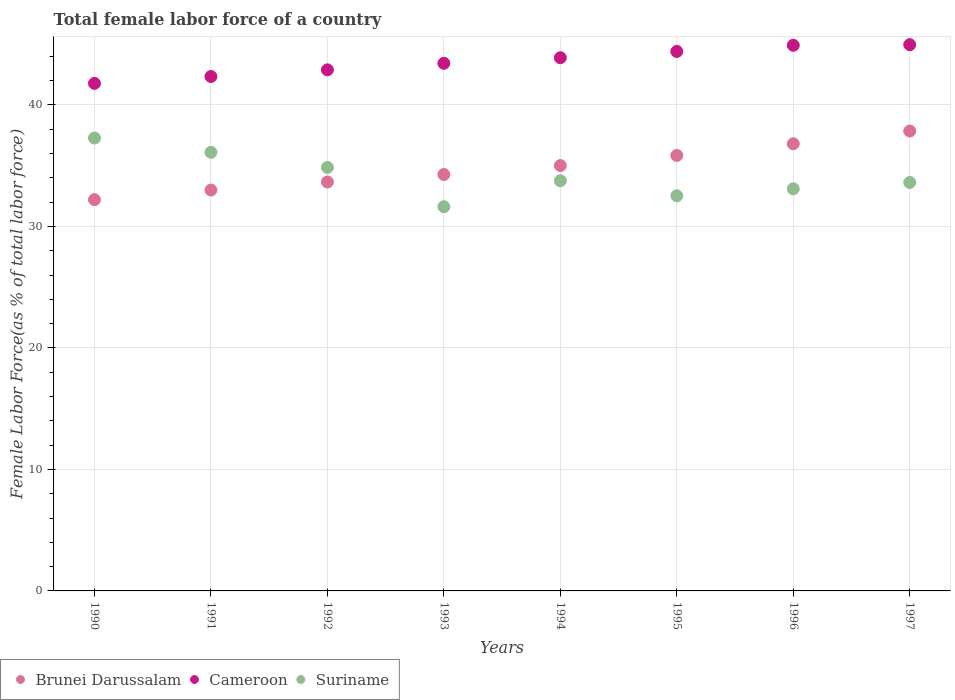How many different coloured dotlines are there?
Your answer should be very brief. 3. What is the percentage of female labor force in Cameroon in 1990?
Your answer should be very brief. 41.78. Across all years, what is the maximum percentage of female labor force in Cameroon?
Provide a short and direct response. 44.96. Across all years, what is the minimum percentage of female labor force in Suriname?
Your response must be concise. 31.62. In which year was the percentage of female labor force in Suriname maximum?
Your response must be concise. 1990. What is the total percentage of female labor force in Suriname in the graph?
Provide a short and direct response. 272.87. What is the difference between the percentage of female labor force in Suriname in 1990 and that in 1991?
Your answer should be very brief. 1.18. What is the difference between the percentage of female labor force in Suriname in 1992 and the percentage of female labor force in Brunei Darussalam in 1995?
Give a very brief answer. -0.99. What is the average percentage of female labor force in Cameroon per year?
Provide a succinct answer. 43.58. In the year 1990, what is the difference between the percentage of female labor force in Cameroon and percentage of female labor force in Brunei Darussalam?
Your answer should be compact. 9.57. What is the ratio of the percentage of female labor force in Cameroon in 1992 to that in 1994?
Provide a short and direct response. 0.98. Is the difference between the percentage of female labor force in Cameroon in 1990 and 1993 greater than the difference between the percentage of female labor force in Brunei Darussalam in 1990 and 1993?
Your answer should be very brief. Yes. What is the difference between the highest and the second highest percentage of female labor force in Suriname?
Offer a very short reply. 1.18. What is the difference between the highest and the lowest percentage of female labor force in Brunei Darussalam?
Your response must be concise. 5.65. In how many years, is the percentage of female labor force in Brunei Darussalam greater than the average percentage of female labor force in Brunei Darussalam taken over all years?
Ensure brevity in your answer.  4. Is it the case that in every year, the sum of the percentage of female labor force in Cameroon and percentage of female labor force in Brunei Darussalam  is greater than the percentage of female labor force in Suriname?
Ensure brevity in your answer.  Yes. Is the percentage of female labor force in Suriname strictly greater than the percentage of female labor force in Brunei Darussalam over the years?
Provide a short and direct response. No. Is the percentage of female labor force in Suriname strictly less than the percentage of female labor force in Brunei Darussalam over the years?
Your response must be concise. No. How many years are there in the graph?
Provide a short and direct response. 8. Does the graph contain any zero values?
Your answer should be very brief. No. Does the graph contain grids?
Offer a terse response. Yes. What is the title of the graph?
Give a very brief answer. Total female labor force of a country. What is the label or title of the Y-axis?
Your response must be concise. Female Labor Force(as % of total labor force). What is the Female Labor Force(as % of total labor force) in Brunei Darussalam in 1990?
Keep it short and to the point. 32.2. What is the Female Labor Force(as % of total labor force) in Cameroon in 1990?
Ensure brevity in your answer.  41.78. What is the Female Labor Force(as % of total labor force) in Suriname in 1990?
Give a very brief answer. 37.28. What is the Female Labor Force(as % of total labor force) of Brunei Darussalam in 1991?
Your response must be concise. 33. What is the Female Labor Force(as % of total labor force) in Cameroon in 1991?
Give a very brief answer. 42.34. What is the Female Labor Force(as % of total labor force) in Suriname in 1991?
Ensure brevity in your answer.  36.1. What is the Female Labor Force(as % of total labor force) of Brunei Darussalam in 1992?
Make the answer very short. 33.66. What is the Female Labor Force(as % of total labor force) of Cameroon in 1992?
Give a very brief answer. 42.89. What is the Female Labor Force(as % of total labor force) of Suriname in 1992?
Your response must be concise. 34.86. What is the Female Labor Force(as % of total labor force) of Brunei Darussalam in 1993?
Make the answer very short. 34.28. What is the Female Labor Force(as % of total labor force) in Cameroon in 1993?
Give a very brief answer. 43.43. What is the Female Labor Force(as % of total labor force) of Suriname in 1993?
Your answer should be very brief. 31.62. What is the Female Labor Force(as % of total labor force) of Brunei Darussalam in 1994?
Give a very brief answer. 35.01. What is the Female Labor Force(as % of total labor force) of Cameroon in 1994?
Ensure brevity in your answer.  43.89. What is the Female Labor Force(as % of total labor force) of Suriname in 1994?
Provide a short and direct response. 33.76. What is the Female Labor Force(as % of total labor force) in Brunei Darussalam in 1995?
Offer a terse response. 35.85. What is the Female Labor Force(as % of total labor force) in Cameroon in 1995?
Offer a very short reply. 44.4. What is the Female Labor Force(as % of total labor force) of Suriname in 1995?
Provide a short and direct response. 32.53. What is the Female Labor Force(as % of total labor force) in Brunei Darussalam in 1996?
Offer a very short reply. 36.81. What is the Female Labor Force(as % of total labor force) of Cameroon in 1996?
Provide a succinct answer. 44.91. What is the Female Labor Force(as % of total labor force) of Suriname in 1996?
Ensure brevity in your answer.  33.1. What is the Female Labor Force(as % of total labor force) in Brunei Darussalam in 1997?
Offer a terse response. 37.86. What is the Female Labor Force(as % of total labor force) in Cameroon in 1997?
Offer a terse response. 44.96. What is the Female Labor Force(as % of total labor force) of Suriname in 1997?
Provide a succinct answer. 33.62. Across all years, what is the maximum Female Labor Force(as % of total labor force) in Brunei Darussalam?
Provide a short and direct response. 37.86. Across all years, what is the maximum Female Labor Force(as % of total labor force) of Cameroon?
Offer a very short reply. 44.96. Across all years, what is the maximum Female Labor Force(as % of total labor force) of Suriname?
Make the answer very short. 37.28. Across all years, what is the minimum Female Labor Force(as % of total labor force) in Brunei Darussalam?
Your answer should be compact. 32.2. Across all years, what is the minimum Female Labor Force(as % of total labor force) in Cameroon?
Provide a succinct answer. 41.78. Across all years, what is the minimum Female Labor Force(as % of total labor force) of Suriname?
Your response must be concise. 31.62. What is the total Female Labor Force(as % of total labor force) of Brunei Darussalam in the graph?
Offer a very short reply. 278.66. What is the total Female Labor Force(as % of total labor force) of Cameroon in the graph?
Offer a very short reply. 348.61. What is the total Female Labor Force(as % of total labor force) in Suriname in the graph?
Your answer should be compact. 272.87. What is the difference between the Female Labor Force(as % of total labor force) in Brunei Darussalam in 1990 and that in 1991?
Your answer should be compact. -0.79. What is the difference between the Female Labor Force(as % of total labor force) in Cameroon in 1990 and that in 1991?
Ensure brevity in your answer.  -0.57. What is the difference between the Female Labor Force(as % of total labor force) in Suriname in 1990 and that in 1991?
Your answer should be very brief. 1.18. What is the difference between the Female Labor Force(as % of total labor force) of Brunei Darussalam in 1990 and that in 1992?
Your answer should be very brief. -1.46. What is the difference between the Female Labor Force(as % of total labor force) of Cameroon in 1990 and that in 1992?
Make the answer very short. -1.11. What is the difference between the Female Labor Force(as % of total labor force) of Suriname in 1990 and that in 1992?
Offer a terse response. 2.42. What is the difference between the Female Labor Force(as % of total labor force) in Brunei Darussalam in 1990 and that in 1993?
Provide a short and direct response. -2.07. What is the difference between the Female Labor Force(as % of total labor force) of Cameroon in 1990 and that in 1993?
Your response must be concise. -1.65. What is the difference between the Female Labor Force(as % of total labor force) in Suriname in 1990 and that in 1993?
Make the answer very short. 5.66. What is the difference between the Female Labor Force(as % of total labor force) of Brunei Darussalam in 1990 and that in 1994?
Offer a terse response. -2.81. What is the difference between the Female Labor Force(as % of total labor force) in Cameroon in 1990 and that in 1994?
Ensure brevity in your answer.  -2.11. What is the difference between the Female Labor Force(as % of total labor force) in Suriname in 1990 and that in 1994?
Your response must be concise. 3.52. What is the difference between the Female Labor Force(as % of total labor force) in Brunei Darussalam in 1990 and that in 1995?
Your response must be concise. -3.64. What is the difference between the Female Labor Force(as % of total labor force) of Cameroon in 1990 and that in 1995?
Ensure brevity in your answer.  -2.63. What is the difference between the Female Labor Force(as % of total labor force) in Suriname in 1990 and that in 1995?
Keep it short and to the point. 4.75. What is the difference between the Female Labor Force(as % of total labor force) of Brunei Darussalam in 1990 and that in 1996?
Keep it short and to the point. -4.6. What is the difference between the Female Labor Force(as % of total labor force) in Cameroon in 1990 and that in 1996?
Your response must be concise. -3.13. What is the difference between the Female Labor Force(as % of total labor force) of Suriname in 1990 and that in 1996?
Keep it short and to the point. 4.18. What is the difference between the Female Labor Force(as % of total labor force) of Brunei Darussalam in 1990 and that in 1997?
Provide a succinct answer. -5.65. What is the difference between the Female Labor Force(as % of total labor force) in Cameroon in 1990 and that in 1997?
Provide a short and direct response. -3.19. What is the difference between the Female Labor Force(as % of total labor force) in Suriname in 1990 and that in 1997?
Your response must be concise. 3.65. What is the difference between the Female Labor Force(as % of total labor force) in Brunei Darussalam in 1991 and that in 1992?
Your answer should be very brief. -0.66. What is the difference between the Female Labor Force(as % of total labor force) in Cameroon in 1991 and that in 1992?
Give a very brief answer. -0.55. What is the difference between the Female Labor Force(as % of total labor force) of Suriname in 1991 and that in 1992?
Ensure brevity in your answer.  1.24. What is the difference between the Female Labor Force(as % of total labor force) of Brunei Darussalam in 1991 and that in 1993?
Your response must be concise. -1.28. What is the difference between the Female Labor Force(as % of total labor force) of Cameroon in 1991 and that in 1993?
Your answer should be compact. -1.09. What is the difference between the Female Labor Force(as % of total labor force) in Suriname in 1991 and that in 1993?
Provide a short and direct response. 4.48. What is the difference between the Female Labor Force(as % of total labor force) in Brunei Darussalam in 1991 and that in 1994?
Make the answer very short. -2.02. What is the difference between the Female Labor Force(as % of total labor force) of Cameroon in 1991 and that in 1994?
Offer a terse response. -1.55. What is the difference between the Female Labor Force(as % of total labor force) of Suriname in 1991 and that in 1994?
Your response must be concise. 2.34. What is the difference between the Female Labor Force(as % of total labor force) of Brunei Darussalam in 1991 and that in 1995?
Your answer should be very brief. -2.85. What is the difference between the Female Labor Force(as % of total labor force) of Cameroon in 1991 and that in 1995?
Your answer should be very brief. -2.06. What is the difference between the Female Labor Force(as % of total labor force) of Suriname in 1991 and that in 1995?
Your answer should be compact. 3.58. What is the difference between the Female Labor Force(as % of total labor force) of Brunei Darussalam in 1991 and that in 1996?
Provide a succinct answer. -3.81. What is the difference between the Female Labor Force(as % of total labor force) of Cameroon in 1991 and that in 1996?
Your answer should be very brief. -2.57. What is the difference between the Female Labor Force(as % of total labor force) of Suriname in 1991 and that in 1996?
Make the answer very short. 3. What is the difference between the Female Labor Force(as % of total labor force) of Brunei Darussalam in 1991 and that in 1997?
Offer a very short reply. -4.86. What is the difference between the Female Labor Force(as % of total labor force) in Cameroon in 1991 and that in 1997?
Ensure brevity in your answer.  -2.62. What is the difference between the Female Labor Force(as % of total labor force) in Suriname in 1991 and that in 1997?
Ensure brevity in your answer.  2.48. What is the difference between the Female Labor Force(as % of total labor force) in Brunei Darussalam in 1992 and that in 1993?
Provide a short and direct response. -0.62. What is the difference between the Female Labor Force(as % of total labor force) in Cameroon in 1992 and that in 1993?
Your response must be concise. -0.54. What is the difference between the Female Labor Force(as % of total labor force) in Suriname in 1992 and that in 1993?
Your answer should be very brief. 3.24. What is the difference between the Female Labor Force(as % of total labor force) of Brunei Darussalam in 1992 and that in 1994?
Your answer should be compact. -1.35. What is the difference between the Female Labor Force(as % of total labor force) of Cameroon in 1992 and that in 1994?
Your response must be concise. -1. What is the difference between the Female Labor Force(as % of total labor force) in Suriname in 1992 and that in 1994?
Your answer should be compact. 1.1. What is the difference between the Female Labor Force(as % of total labor force) of Brunei Darussalam in 1992 and that in 1995?
Give a very brief answer. -2.19. What is the difference between the Female Labor Force(as % of total labor force) of Cameroon in 1992 and that in 1995?
Give a very brief answer. -1.52. What is the difference between the Female Labor Force(as % of total labor force) of Suriname in 1992 and that in 1995?
Keep it short and to the point. 2.33. What is the difference between the Female Labor Force(as % of total labor force) in Brunei Darussalam in 1992 and that in 1996?
Keep it short and to the point. -3.15. What is the difference between the Female Labor Force(as % of total labor force) in Cameroon in 1992 and that in 1996?
Offer a terse response. -2.02. What is the difference between the Female Labor Force(as % of total labor force) of Suriname in 1992 and that in 1996?
Offer a very short reply. 1.76. What is the difference between the Female Labor Force(as % of total labor force) in Brunei Darussalam in 1992 and that in 1997?
Ensure brevity in your answer.  -4.2. What is the difference between the Female Labor Force(as % of total labor force) of Cameroon in 1992 and that in 1997?
Make the answer very short. -2.07. What is the difference between the Female Labor Force(as % of total labor force) of Suriname in 1992 and that in 1997?
Your answer should be very brief. 1.24. What is the difference between the Female Labor Force(as % of total labor force) of Brunei Darussalam in 1993 and that in 1994?
Your answer should be compact. -0.73. What is the difference between the Female Labor Force(as % of total labor force) in Cameroon in 1993 and that in 1994?
Your response must be concise. -0.46. What is the difference between the Female Labor Force(as % of total labor force) of Suriname in 1993 and that in 1994?
Give a very brief answer. -2.14. What is the difference between the Female Labor Force(as % of total labor force) in Brunei Darussalam in 1993 and that in 1995?
Keep it short and to the point. -1.57. What is the difference between the Female Labor Force(as % of total labor force) in Cameroon in 1993 and that in 1995?
Offer a terse response. -0.97. What is the difference between the Female Labor Force(as % of total labor force) in Suriname in 1993 and that in 1995?
Your answer should be compact. -0.9. What is the difference between the Female Labor Force(as % of total labor force) in Brunei Darussalam in 1993 and that in 1996?
Provide a short and direct response. -2.53. What is the difference between the Female Labor Force(as % of total labor force) in Cameroon in 1993 and that in 1996?
Your response must be concise. -1.48. What is the difference between the Female Labor Force(as % of total labor force) of Suriname in 1993 and that in 1996?
Offer a very short reply. -1.48. What is the difference between the Female Labor Force(as % of total labor force) of Brunei Darussalam in 1993 and that in 1997?
Your response must be concise. -3.58. What is the difference between the Female Labor Force(as % of total labor force) in Cameroon in 1993 and that in 1997?
Your answer should be compact. -1.53. What is the difference between the Female Labor Force(as % of total labor force) of Suriname in 1993 and that in 1997?
Give a very brief answer. -2. What is the difference between the Female Labor Force(as % of total labor force) of Brunei Darussalam in 1994 and that in 1995?
Your answer should be compact. -0.83. What is the difference between the Female Labor Force(as % of total labor force) in Cameroon in 1994 and that in 1995?
Ensure brevity in your answer.  -0.52. What is the difference between the Female Labor Force(as % of total labor force) of Suriname in 1994 and that in 1995?
Make the answer very short. 1.23. What is the difference between the Female Labor Force(as % of total labor force) in Brunei Darussalam in 1994 and that in 1996?
Your response must be concise. -1.8. What is the difference between the Female Labor Force(as % of total labor force) of Cameroon in 1994 and that in 1996?
Ensure brevity in your answer.  -1.02. What is the difference between the Female Labor Force(as % of total labor force) of Suriname in 1994 and that in 1996?
Provide a short and direct response. 0.66. What is the difference between the Female Labor Force(as % of total labor force) of Brunei Darussalam in 1994 and that in 1997?
Give a very brief answer. -2.84. What is the difference between the Female Labor Force(as % of total labor force) of Cameroon in 1994 and that in 1997?
Give a very brief answer. -1.07. What is the difference between the Female Labor Force(as % of total labor force) in Suriname in 1994 and that in 1997?
Provide a succinct answer. 0.14. What is the difference between the Female Labor Force(as % of total labor force) of Brunei Darussalam in 1995 and that in 1996?
Ensure brevity in your answer.  -0.96. What is the difference between the Female Labor Force(as % of total labor force) in Cameroon in 1995 and that in 1996?
Ensure brevity in your answer.  -0.51. What is the difference between the Female Labor Force(as % of total labor force) in Suriname in 1995 and that in 1996?
Keep it short and to the point. -0.58. What is the difference between the Female Labor Force(as % of total labor force) of Brunei Darussalam in 1995 and that in 1997?
Your response must be concise. -2.01. What is the difference between the Female Labor Force(as % of total labor force) of Cameroon in 1995 and that in 1997?
Your response must be concise. -0.56. What is the difference between the Female Labor Force(as % of total labor force) of Suriname in 1995 and that in 1997?
Your response must be concise. -1.1. What is the difference between the Female Labor Force(as % of total labor force) of Brunei Darussalam in 1996 and that in 1997?
Your answer should be compact. -1.05. What is the difference between the Female Labor Force(as % of total labor force) of Cameroon in 1996 and that in 1997?
Offer a very short reply. -0.05. What is the difference between the Female Labor Force(as % of total labor force) of Suriname in 1996 and that in 1997?
Ensure brevity in your answer.  -0.52. What is the difference between the Female Labor Force(as % of total labor force) of Brunei Darussalam in 1990 and the Female Labor Force(as % of total labor force) of Cameroon in 1991?
Your response must be concise. -10.14. What is the difference between the Female Labor Force(as % of total labor force) of Brunei Darussalam in 1990 and the Female Labor Force(as % of total labor force) of Suriname in 1991?
Provide a succinct answer. -3.9. What is the difference between the Female Labor Force(as % of total labor force) of Cameroon in 1990 and the Female Labor Force(as % of total labor force) of Suriname in 1991?
Your response must be concise. 5.67. What is the difference between the Female Labor Force(as % of total labor force) of Brunei Darussalam in 1990 and the Female Labor Force(as % of total labor force) of Cameroon in 1992?
Give a very brief answer. -10.69. What is the difference between the Female Labor Force(as % of total labor force) of Brunei Darussalam in 1990 and the Female Labor Force(as % of total labor force) of Suriname in 1992?
Offer a terse response. -2.66. What is the difference between the Female Labor Force(as % of total labor force) in Cameroon in 1990 and the Female Labor Force(as % of total labor force) in Suriname in 1992?
Your answer should be compact. 6.92. What is the difference between the Female Labor Force(as % of total labor force) in Brunei Darussalam in 1990 and the Female Labor Force(as % of total labor force) in Cameroon in 1993?
Provide a succinct answer. -11.23. What is the difference between the Female Labor Force(as % of total labor force) of Brunei Darussalam in 1990 and the Female Labor Force(as % of total labor force) of Suriname in 1993?
Provide a succinct answer. 0.58. What is the difference between the Female Labor Force(as % of total labor force) in Cameroon in 1990 and the Female Labor Force(as % of total labor force) in Suriname in 1993?
Offer a very short reply. 10.15. What is the difference between the Female Labor Force(as % of total labor force) of Brunei Darussalam in 1990 and the Female Labor Force(as % of total labor force) of Cameroon in 1994?
Make the answer very short. -11.68. What is the difference between the Female Labor Force(as % of total labor force) in Brunei Darussalam in 1990 and the Female Labor Force(as % of total labor force) in Suriname in 1994?
Your answer should be compact. -1.56. What is the difference between the Female Labor Force(as % of total labor force) of Cameroon in 1990 and the Female Labor Force(as % of total labor force) of Suriname in 1994?
Offer a terse response. 8.02. What is the difference between the Female Labor Force(as % of total labor force) of Brunei Darussalam in 1990 and the Female Labor Force(as % of total labor force) of Cameroon in 1995?
Provide a short and direct response. -12.2. What is the difference between the Female Labor Force(as % of total labor force) in Brunei Darussalam in 1990 and the Female Labor Force(as % of total labor force) in Suriname in 1995?
Give a very brief answer. -0.32. What is the difference between the Female Labor Force(as % of total labor force) in Cameroon in 1990 and the Female Labor Force(as % of total labor force) in Suriname in 1995?
Provide a short and direct response. 9.25. What is the difference between the Female Labor Force(as % of total labor force) in Brunei Darussalam in 1990 and the Female Labor Force(as % of total labor force) in Cameroon in 1996?
Make the answer very short. -12.71. What is the difference between the Female Labor Force(as % of total labor force) in Brunei Darussalam in 1990 and the Female Labor Force(as % of total labor force) in Suriname in 1996?
Ensure brevity in your answer.  -0.9. What is the difference between the Female Labor Force(as % of total labor force) in Cameroon in 1990 and the Female Labor Force(as % of total labor force) in Suriname in 1996?
Your answer should be compact. 8.68. What is the difference between the Female Labor Force(as % of total labor force) of Brunei Darussalam in 1990 and the Female Labor Force(as % of total labor force) of Cameroon in 1997?
Your answer should be very brief. -12.76. What is the difference between the Female Labor Force(as % of total labor force) in Brunei Darussalam in 1990 and the Female Labor Force(as % of total labor force) in Suriname in 1997?
Give a very brief answer. -1.42. What is the difference between the Female Labor Force(as % of total labor force) in Cameroon in 1990 and the Female Labor Force(as % of total labor force) in Suriname in 1997?
Your answer should be very brief. 8.15. What is the difference between the Female Labor Force(as % of total labor force) in Brunei Darussalam in 1991 and the Female Labor Force(as % of total labor force) in Cameroon in 1992?
Ensure brevity in your answer.  -9.89. What is the difference between the Female Labor Force(as % of total labor force) in Brunei Darussalam in 1991 and the Female Labor Force(as % of total labor force) in Suriname in 1992?
Offer a terse response. -1.86. What is the difference between the Female Labor Force(as % of total labor force) in Cameroon in 1991 and the Female Labor Force(as % of total labor force) in Suriname in 1992?
Provide a short and direct response. 7.48. What is the difference between the Female Labor Force(as % of total labor force) in Brunei Darussalam in 1991 and the Female Labor Force(as % of total labor force) in Cameroon in 1993?
Offer a terse response. -10.43. What is the difference between the Female Labor Force(as % of total labor force) in Brunei Darussalam in 1991 and the Female Labor Force(as % of total labor force) in Suriname in 1993?
Your answer should be very brief. 1.37. What is the difference between the Female Labor Force(as % of total labor force) in Cameroon in 1991 and the Female Labor Force(as % of total labor force) in Suriname in 1993?
Provide a succinct answer. 10.72. What is the difference between the Female Labor Force(as % of total labor force) in Brunei Darussalam in 1991 and the Female Labor Force(as % of total labor force) in Cameroon in 1994?
Offer a very short reply. -10.89. What is the difference between the Female Labor Force(as % of total labor force) of Brunei Darussalam in 1991 and the Female Labor Force(as % of total labor force) of Suriname in 1994?
Your answer should be compact. -0.76. What is the difference between the Female Labor Force(as % of total labor force) of Cameroon in 1991 and the Female Labor Force(as % of total labor force) of Suriname in 1994?
Provide a succinct answer. 8.58. What is the difference between the Female Labor Force(as % of total labor force) of Brunei Darussalam in 1991 and the Female Labor Force(as % of total labor force) of Cameroon in 1995?
Give a very brief answer. -11.41. What is the difference between the Female Labor Force(as % of total labor force) of Brunei Darussalam in 1991 and the Female Labor Force(as % of total labor force) of Suriname in 1995?
Offer a very short reply. 0.47. What is the difference between the Female Labor Force(as % of total labor force) in Cameroon in 1991 and the Female Labor Force(as % of total labor force) in Suriname in 1995?
Provide a succinct answer. 9.82. What is the difference between the Female Labor Force(as % of total labor force) in Brunei Darussalam in 1991 and the Female Labor Force(as % of total labor force) in Cameroon in 1996?
Keep it short and to the point. -11.92. What is the difference between the Female Labor Force(as % of total labor force) in Brunei Darussalam in 1991 and the Female Labor Force(as % of total labor force) in Suriname in 1996?
Make the answer very short. -0.1. What is the difference between the Female Labor Force(as % of total labor force) of Cameroon in 1991 and the Female Labor Force(as % of total labor force) of Suriname in 1996?
Your answer should be very brief. 9.24. What is the difference between the Female Labor Force(as % of total labor force) in Brunei Darussalam in 1991 and the Female Labor Force(as % of total labor force) in Cameroon in 1997?
Offer a terse response. -11.97. What is the difference between the Female Labor Force(as % of total labor force) in Brunei Darussalam in 1991 and the Female Labor Force(as % of total labor force) in Suriname in 1997?
Give a very brief answer. -0.63. What is the difference between the Female Labor Force(as % of total labor force) in Cameroon in 1991 and the Female Labor Force(as % of total labor force) in Suriname in 1997?
Offer a very short reply. 8.72. What is the difference between the Female Labor Force(as % of total labor force) of Brunei Darussalam in 1992 and the Female Labor Force(as % of total labor force) of Cameroon in 1993?
Your answer should be compact. -9.77. What is the difference between the Female Labor Force(as % of total labor force) of Brunei Darussalam in 1992 and the Female Labor Force(as % of total labor force) of Suriname in 1993?
Provide a short and direct response. 2.04. What is the difference between the Female Labor Force(as % of total labor force) of Cameroon in 1992 and the Female Labor Force(as % of total labor force) of Suriname in 1993?
Your response must be concise. 11.27. What is the difference between the Female Labor Force(as % of total labor force) of Brunei Darussalam in 1992 and the Female Labor Force(as % of total labor force) of Cameroon in 1994?
Your answer should be compact. -10.23. What is the difference between the Female Labor Force(as % of total labor force) of Brunei Darussalam in 1992 and the Female Labor Force(as % of total labor force) of Suriname in 1994?
Make the answer very short. -0.1. What is the difference between the Female Labor Force(as % of total labor force) in Cameroon in 1992 and the Female Labor Force(as % of total labor force) in Suriname in 1994?
Your response must be concise. 9.13. What is the difference between the Female Labor Force(as % of total labor force) in Brunei Darussalam in 1992 and the Female Labor Force(as % of total labor force) in Cameroon in 1995?
Give a very brief answer. -10.74. What is the difference between the Female Labor Force(as % of total labor force) in Brunei Darussalam in 1992 and the Female Labor Force(as % of total labor force) in Suriname in 1995?
Keep it short and to the point. 1.13. What is the difference between the Female Labor Force(as % of total labor force) of Cameroon in 1992 and the Female Labor Force(as % of total labor force) of Suriname in 1995?
Your response must be concise. 10.36. What is the difference between the Female Labor Force(as % of total labor force) in Brunei Darussalam in 1992 and the Female Labor Force(as % of total labor force) in Cameroon in 1996?
Offer a very short reply. -11.25. What is the difference between the Female Labor Force(as % of total labor force) of Brunei Darussalam in 1992 and the Female Labor Force(as % of total labor force) of Suriname in 1996?
Give a very brief answer. 0.56. What is the difference between the Female Labor Force(as % of total labor force) in Cameroon in 1992 and the Female Labor Force(as % of total labor force) in Suriname in 1996?
Offer a very short reply. 9.79. What is the difference between the Female Labor Force(as % of total labor force) of Brunei Darussalam in 1992 and the Female Labor Force(as % of total labor force) of Cameroon in 1997?
Offer a terse response. -11.3. What is the difference between the Female Labor Force(as % of total labor force) of Brunei Darussalam in 1992 and the Female Labor Force(as % of total labor force) of Suriname in 1997?
Offer a terse response. 0.04. What is the difference between the Female Labor Force(as % of total labor force) of Cameroon in 1992 and the Female Labor Force(as % of total labor force) of Suriname in 1997?
Your answer should be compact. 9.27. What is the difference between the Female Labor Force(as % of total labor force) of Brunei Darussalam in 1993 and the Female Labor Force(as % of total labor force) of Cameroon in 1994?
Offer a very short reply. -9.61. What is the difference between the Female Labor Force(as % of total labor force) of Brunei Darussalam in 1993 and the Female Labor Force(as % of total labor force) of Suriname in 1994?
Provide a short and direct response. 0.52. What is the difference between the Female Labor Force(as % of total labor force) of Cameroon in 1993 and the Female Labor Force(as % of total labor force) of Suriname in 1994?
Offer a terse response. 9.67. What is the difference between the Female Labor Force(as % of total labor force) of Brunei Darussalam in 1993 and the Female Labor Force(as % of total labor force) of Cameroon in 1995?
Give a very brief answer. -10.13. What is the difference between the Female Labor Force(as % of total labor force) of Brunei Darussalam in 1993 and the Female Labor Force(as % of total labor force) of Suriname in 1995?
Offer a terse response. 1.75. What is the difference between the Female Labor Force(as % of total labor force) of Cameroon in 1993 and the Female Labor Force(as % of total labor force) of Suriname in 1995?
Make the answer very short. 10.9. What is the difference between the Female Labor Force(as % of total labor force) in Brunei Darussalam in 1993 and the Female Labor Force(as % of total labor force) in Cameroon in 1996?
Your answer should be very brief. -10.63. What is the difference between the Female Labor Force(as % of total labor force) of Brunei Darussalam in 1993 and the Female Labor Force(as % of total labor force) of Suriname in 1996?
Offer a very short reply. 1.18. What is the difference between the Female Labor Force(as % of total labor force) of Cameroon in 1993 and the Female Labor Force(as % of total labor force) of Suriname in 1996?
Provide a short and direct response. 10.33. What is the difference between the Female Labor Force(as % of total labor force) in Brunei Darussalam in 1993 and the Female Labor Force(as % of total labor force) in Cameroon in 1997?
Offer a very short reply. -10.69. What is the difference between the Female Labor Force(as % of total labor force) of Brunei Darussalam in 1993 and the Female Labor Force(as % of total labor force) of Suriname in 1997?
Offer a terse response. 0.65. What is the difference between the Female Labor Force(as % of total labor force) in Cameroon in 1993 and the Female Labor Force(as % of total labor force) in Suriname in 1997?
Give a very brief answer. 9.81. What is the difference between the Female Labor Force(as % of total labor force) in Brunei Darussalam in 1994 and the Female Labor Force(as % of total labor force) in Cameroon in 1995?
Your answer should be very brief. -9.39. What is the difference between the Female Labor Force(as % of total labor force) of Brunei Darussalam in 1994 and the Female Labor Force(as % of total labor force) of Suriname in 1995?
Your answer should be very brief. 2.49. What is the difference between the Female Labor Force(as % of total labor force) in Cameroon in 1994 and the Female Labor Force(as % of total labor force) in Suriname in 1995?
Offer a very short reply. 11.36. What is the difference between the Female Labor Force(as % of total labor force) of Brunei Darussalam in 1994 and the Female Labor Force(as % of total labor force) of Cameroon in 1996?
Provide a short and direct response. -9.9. What is the difference between the Female Labor Force(as % of total labor force) of Brunei Darussalam in 1994 and the Female Labor Force(as % of total labor force) of Suriname in 1996?
Offer a very short reply. 1.91. What is the difference between the Female Labor Force(as % of total labor force) in Cameroon in 1994 and the Female Labor Force(as % of total labor force) in Suriname in 1996?
Your response must be concise. 10.79. What is the difference between the Female Labor Force(as % of total labor force) in Brunei Darussalam in 1994 and the Female Labor Force(as % of total labor force) in Cameroon in 1997?
Provide a short and direct response. -9.95. What is the difference between the Female Labor Force(as % of total labor force) of Brunei Darussalam in 1994 and the Female Labor Force(as % of total labor force) of Suriname in 1997?
Provide a succinct answer. 1.39. What is the difference between the Female Labor Force(as % of total labor force) of Cameroon in 1994 and the Female Labor Force(as % of total labor force) of Suriname in 1997?
Give a very brief answer. 10.26. What is the difference between the Female Labor Force(as % of total labor force) of Brunei Darussalam in 1995 and the Female Labor Force(as % of total labor force) of Cameroon in 1996?
Give a very brief answer. -9.07. What is the difference between the Female Labor Force(as % of total labor force) of Brunei Darussalam in 1995 and the Female Labor Force(as % of total labor force) of Suriname in 1996?
Your answer should be compact. 2.75. What is the difference between the Female Labor Force(as % of total labor force) of Cameroon in 1995 and the Female Labor Force(as % of total labor force) of Suriname in 1996?
Your response must be concise. 11.3. What is the difference between the Female Labor Force(as % of total labor force) in Brunei Darussalam in 1995 and the Female Labor Force(as % of total labor force) in Cameroon in 1997?
Keep it short and to the point. -9.12. What is the difference between the Female Labor Force(as % of total labor force) in Brunei Darussalam in 1995 and the Female Labor Force(as % of total labor force) in Suriname in 1997?
Give a very brief answer. 2.22. What is the difference between the Female Labor Force(as % of total labor force) of Cameroon in 1995 and the Female Labor Force(as % of total labor force) of Suriname in 1997?
Make the answer very short. 10.78. What is the difference between the Female Labor Force(as % of total labor force) in Brunei Darussalam in 1996 and the Female Labor Force(as % of total labor force) in Cameroon in 1997?
Keep it short and to the point. -8.15. What is the difference between the Female Labor Force(as % of total labor force) in Brunei Darussalam in 1996 and the Female Labor Force(as % of total labor force) in Suriname in 1997?
Provide a succinct answer. 3.18. What is the difference between the Female Labor Force(as % of total labor force) in Cameroon in 1996 and the Female Labor Force(as % of total labor force) in Suriname in 1997?
Your answer should be very brief. 11.29. What is the average Female Labor Force(as % of total labor force) of Brunei Darussalam per year?
Keep it short and to the point. 34.83. What is the average Female Labor Force(as % of total labor force) of Cameroon per year?
Offer a very short reply. 43.58. What is the average Female Labor Force(as % of total labor force) in Suriname per year?
Ensure brevity in your answer.  34.11. In the year 1990, what is the difference between the Female Labor Force(as % of total labor force) in Brunei Darussalam and Female Labor Force(as % of total labor force) in Cameroon?
Your answer should be compact. -9.57. In the year 1990, what is the difference between the Female Labor Force(as % of total labor force) of Brunei Darussalam and Female Labor Force(as % of total labor force) of Suriname?
Provide a short and direct response. -5.07. In the year 1990, what is the difference between the Female Labor Force(as % of total labor force) of Cameroon and Female Labor Force(as % of total labor force) of Suriname?
Your answer should be very brief. 4.5. In the year 1991, what is the difference between the Female Labor Force(as % of total labor force) of Brunei Darussalam and Female Labor Force(as % of total labor force) of Cameroon?
Your answer should be very brief. -9.35. In the year 1991, what is the difference between the Female Labor Force(as % of total labor force) of Brunei Darussalam and Female Labor Force(as % of total labor force) of Suriname?
Your answer should be very brief. -3.11. In the year 1991, what is the difference between the Female Labor Force(as % of total labor force) in Cameroon and Female Labor Force(as % of total labor force) in Suriname?
Your answer should be compact. 6.24. In the year 1992, what is the difference between the Female Labor Force(as % of total labor force) in Brunei Darussalam and Female Labor Force(as % of total labor force) in Cameroon?
Your response must be concise. -9.23. In the year 1992, what is the difference between the Female Labor Force(as % of total labor force) in Brunei Darussalam and Female Labor Force(as % of total labor force) in Suriname?
Keep it short and to the point. -1.2. In the year 1992, what is the difference between the Female Labor Force(as % of total labor force) of Cameroon and Female Labor Force(as % of total labor force) of Suriname?
Your response must be concise. 8.03. In the year 1993, what is the difference between the Female Labor Force(as % of total labor force) in Brunei Darussalam and Female Labor Force(as % of total labor force) in Cameroon?
Keep it short and to the point. -9.15. In the year 1993, what is the difference between the Female Labor Force(as % of total labor force) in Brunei Darussalam and Female Labor Force(as % of total labor force) in Suriname?
Your response must be concise. 2.65. In the year 1993, what is the difference between the Female Labor Force(as % of total labor force) in Cameroon and Female Labor Force(as % of total labor force) in Suriname?
Your answer should be very brief. 11.81. In the year 1994, what is the difference between the Female Labor Force(as % of total labor force) in Brunei Darussalam and Female Labor Force(as % of total labor force) in Cameroon?
Give a very brief answer. -8.88. In the year 1994, what is the difference between the Female Labor Force(as % of total labor force) of Brunei Darussalam and Female Labor Force(as % of total labor force) of Suriname?
Make the answer very short. 1.25. In the year 1994, what is the difference between the Female Labor Force(as % of total labor force) of Cameroon and Female Labor Force(as % of total labor force) of Suriname?
Make the answer very short. 10.13. In the year 1995, what is the difference between the Female Labor Force(as % of total labor force) in Brunei Darussalam and Female Labor Force(as % of total labor force) in Cameroon?
Give a very brief answer. -8.56. In the year 1995, what is the difference between the Female Labor Force(as % of total labor force) in Brunei Darussalam and Female Labor Force(as % of total labor force) in Suriname?
Make the answer very short. 3.32. In the year 1995, what is the difference between the Female Labor Force(as % of total labor force) in Cameroon and Female Labor Force(as % of total labor force) in Suriname?
Your answer should be compact. 11.88. In the year 1996, what is the difference between the Female Labor Force(as % of total labor force) in Brunei Darussalam and Female Labor Force(as % of total labor force) in Cameroon?
Provide a short and direct response. -8.1. In the year 1996, what is the difference between the Female Labor Force(as % of total labor force) of Brunei Darussalam and Female Labor Force(as % of total labor force) of Suriname?
Your answer should be compact. 3.71. In the year 1996, what is the difference between the Female Labor Force(as % of total labor force) of Cameroon and Female Labor Force(as % of total labor force) of Suriname?
Provide a short and direct response. 11.81. In the year 1997, what is the difference between the Female Labor Force(as % of total labor force) in Brunei Darussalam and Female Labor Force(as % of total labor force) in Cameroon?
Your response must be concise. -7.11. In the year 1997, what is the difference between the Female Labor Force(as % of total labor force) in Brunei Darussalam and Female Labor Force(as % of total labor force) in Suriname?
Make the answer very short. 4.23. In the year 1997, what is the difference between the Female Labor Force(as % of total labor force) of Cameroon and Female Labor Force(as % of total labor force) of Suriname?
Your answer should be compact. 11.34. What is the ratio of the Female Labor Force(as % of total labor force) of Cameroon in 1990 to that in 1991?
Make the answer very short. 0.99. What is the ratio of the Female Labor Force(as % of total labor force) of Suriname in 1990 to that in 1991?
Provide a short and direct response. 1.03. What is the ratio of the Female Labor Force(as % of total labor force) of Brunei Darussalam in 1990 to that in 1992?
Your answer should be compact. 0.96. What is the ratio of the Female Labor Force(as % of total labor force) of Suriname in 1990 to that in 1992?
Your response must be concise. 1.07. What is the ratio of the Female Labor Force(as % of total labor force) of Brunei Darussalam in 1990 to that in 1993?
Give a very brief answer. 0.94. What is the ratio of the Female Labor Force(as % of total labor force) of Cameroon in 1990 to that in 1993?
Make the answer very short. 0.96. What is the ratio of the Female Labor Force(as % of total labor force) in Suriname in 1990 to that in 1993?
Provide a succinct answer. 1.18. What is the ratio of the Female Labor Force(as % of total labor force) of Brunei Darussalam in 1990 to that in 1994?
Your answer should be very brief. 0.92. What is the ratio of the Female Labor Force(as % of total labor force) in Cameroon in 1990 to that in 1994?
Ensure brevity in your answer.  0.95. What is the ratio of the Female Labor Force(as % of total labor force) in Suriname in 1990 to that in 1994?
Make the answer very short. 1.1. What is the ratio of the Female Labor Force(as % of total labor force) in Brunei Darussalam in 1990 to that in 1995?
Provide a succinct answer. 0.9. What is the ratio of the Female Labor Force(as % of total labor force) in Cameroon in 1990 to that in 1995?
Ensure brevity in your answer.  0.94. What is the ratio of the Female Labor Force(as % of total labor force) in Suriname in 1990 to that in 1995?
Keep it short and to the point. 1.15. What is the ratio of the Female Labor Force(as % of total labor force) of Brunei Darussalam in 1990 to that in 1996?
Your answer should be compact. 0.87. What is the ratio of the Female Labor Force(as % of total labor force) in Cameroon in 1990 to that in 1996?
Your response must be concise. 0.93. What is the ratio of the Female Labor Force(as % of total labor force) of Suriname in 1990 to that in 1996?
Your response must be concise. 1.13. What is the ratio of the Female Labor Force(as % of total labor force) in Brunei Darussalam in 1990 to that in 1997?
Make the answer very short. 0.85. What is the ratio of the Female Labor Force(as % of total labor force) in Cameroon in 1990 to that in 1997?
Give a very brief answer. 0.93. What is the ratio of the Female Labor Force(as % of total labor force) of Suriname in 1990 to that in 1997?
Offer a terse response. 1.11. What is the ratio of the Female Labor Force(as % of total labor force) in Brunei Darussalam in 1991 to that in 1992?
Keep it short and to the point. 0.98. What is the ratio of the Female Labor Force(as % of total labor force) in Cameroon in 1991 to that in 1992?
Offer a very short reply. 0.99. What is the ratio of the Female Labor Force(as % of total labor force) of Suriname in 1991 to that in 1992?
Offer a very short reply. 1.04. What is the ratio of the Female Labor Force(as % of total labor force) of Brunei Darussalam in 1991 to that in 1993?
Keep it short and to the point. 0.96. What is the ratio of the Female Labor Force(as % of total labor force) of Suriname in 1991 to that in 1993?
Your answer should be very brief. 1.14. What is the ratio of the Female Labor Force(as % of total labor force) of Brunei Darussalam in 1991 to that in 1994?
Your response must be concise. 0.94. What is the ratio of the Female Labor Force(as % of total labor force) of Cameroon in 1991 to that in 1994?
Provide a short and direct response. 0.96. What is the ratio of the Female Labor Force(as % of total labor force) in Suriname in 1991 to that in 1994?
Give a very brief answer. 1.07. What is the ratio of the Female Labor Force(as % of total labor force) of Brunei Darussalam in 1991 to that in 1995?
Ensure brevity in your answer.  0.92. What is the ratio of the Female Labor Force(as % of total labor force) of Cameroon in 1991 to that in 1995?
Make the answer very short. 0.95. What is the ratio of the Female Labor Force(as % of total labor force) in Suriname in 1991 to that in 1995?
Offer a terse response. 1.11. What is the ratio of the Female Labor Force(as % of total labor force) in Brunei Darussalam in 1991 to that in 1996?
Your answer should be very brief. 0.9. What is the ratio of the Female Labor Force(as % of total labor force) in Cameroon in 1991 to that in 1996?
Provide a short and direct response. 0.94. What is the ratio of the Female Labor Force(as % of total labor force) of Suriname in 1991 to that in 1996?
Provide a succinct answer. 1.09. What is the ratio of the Female Labor Force(as % of total labor force) in Brunei Darussalam in 1991 to that in 1997?
Provide a short and direct response. 0.87. What is the ratio of the Female Labor Force(as % of total labor force) of Cameroon in 1991 to that in 1997?
Keep it short and to the point. 0.94. What is the ratio of the Female Labor Force(as % of total labor force) of Suriname in 1991 to that in 1997?
Give a very brief answer. 1.07. What is the ratio of the Female Labor Force(as % of total labor force) of Brunei Darussalam in 1992 to that in 1993?
Offer a very short reply. 0.98. What is the ratio of the Female Labor Force(as % of total labor force) of Cameroon in 1992 to that in 1993?
Give a very brief answer. 0.99. What is the ratio of the Female Labor Force(as % of total labor force) in Suriname in 1992 to that in 1993?
Your answer should be very brief. 1.1. What is the ratio of the Female Labor Force(as % of total labor force) in Brunei Darussalam in 1992 to that in 1994?
Your answer should be very brief. 0.96. What is the ratio of the Female Labor Force(as % of total labor force) of Cameroon in 1992 to that in 1994?
Provide a succinct answer. 0.98. What is the ratio of the Female Labor Force(as % of total labor force) of Suriname in 1992 to that in 1994?
Offer a terse response. 1.03. What is the ratio of the Female Labor Force(as % of total labor force) in Brunei Darussalam in 1992 to that in 1995?
Give a very brief answer. 0.94. What is the ratio of the Female Labor Force(as % of total labor force) in Cameroon in 1992 to that in 1995?
Ensure brevity in your answer.  0.97. What is the ratio of the Female Labor Force(as % of total labor force) of Suriname in 1992 to that in 1995?
Your response must be concise. 1.07. What is the ratio of the Female Labor Force(as % of total labor force) in Brunei Darussalam in 1992 to that in 1996?
Your response must be concise. 0.91. What is the ratio of the Female Labor Force(as % of total labor force) in Cameroon in 1992 to that in 1996?
Provide a succinct answer. 0.95. What is the ratio of the Female Labor Force(as % of total labor force) of Suriname in 1992 to that in 1996?
Your answer should be compact. 1.05. What is the ratio of the Female Labor Force(as % of total labor force) in Brunei Darussalam in 1992 to that in 1997?
Ensure brevity in your answer.  0.89. What is the ratio of the Female Labor Force(as % of total labor force) in Cameroon in 1992 to that in 1997?
Offer a very short reply. 0.95. What is the ratio of the Female Labor Force(as % of total labor force) of Suriname in 1992 to that in 1997?
Ensure brevity in your answer.  1.04. What is the ratio of the Female Labor Force(as % of total labor force) of Brunei Darussalam in 1993 to that in 1994?
Keep it short and to the point. 0.98. What is the ratio of the Female Labor Force(as % of total labor force) in Cameroon in 1993 to that in 1994?
Your response must be concise. 0.99. What is the ratio of the Female Labor Force(as % of total labor force) in Suriname in 1993 to that in 1994?
Keep it short and to the point. 0.94. What is the ratio of the Female Labor Force(as % of total labor force) of Brunei Darussalam in 1993 to that in 1995?
Keep it short and to the point. 0.96. What is the ratio of the Female Labor Force(as % of total labor force) of Suriname in 1993 to that in 1995?
Provide a short and direct response. 0.97. What is the ratio of the Female Labor Force(as % of total labor force) in Brunei Darussalam in 1993 to that in 1996?
Make the answer very short. 0.93. What is the ratio of the Female Labor Force(as % of total labor force) of Cameroon in 1993 to that in 1996?
Give a very brief answer. 0.97. What is the ratio of the Female Labor Force(as % of total labor force) of Suriname in 1993 to that in 1996?
Offer a very short reply. 0.96. What is the ratio of the Female Labor Force(as % of total labor force) in Brunei Darussalam in 1993 to that in 1997?
Provide a short and direct response. 0.91. What is the ratio of the Female Labor Force(as % of total labor force) of Cameroon in 1993 to that in 1997?
Provide a short and direct response. 0.97. What is the ratio of the Female Labor Force(as % of total labor force) of Suriname in 1993 to that in 1997?
Keep it short and to the point. 0.94. What is the ratio of the Female Labor Force(as % of total labor force) in Brunei Darussalam in 1994 to that in 1995?
Your response must be concise. 0.98. What is the ratio of the Female Labor Force(as % of total labor force) of Cameroon in 1994 to that in 1995?
Provide a succinct answer. 0.99. What is the ratio of the Female Labor Force(as % of total labor force) in Suriname in 1994 to that in 1995?
Your response must be concise. 1.04. What is the ratio of the Female Labor Force(as % of total labor force) of Brunei Darussalam in 1994 to that in 1996?
Your answer should be compact. 0.95. What is the ratio of the Female Labor Force(as % of total labor force) of Cameroon in 1994 to that in 1996?
Your answer should be very brief. 0.98. What is the ratio of the Female Labor Force(as % of total labor force) in Suriname in 1994 to that in 1996?
Offer a very short reply. 1.02. What is the ratio of the Female Labor Force(as % of total labor force) of Brunei Darussalam in 1994 to that in 1997?
Your response must be concise. 0.92. What is the ratio of the Female Labor Force(as % of total labor force) in Cameroon in 1994 to that in 1997?
Offer a very short reply. 0.98. What is the ratio of the Female Labor Force(as % of total labor force) of Suriname in 1994 to that in 1997?
Ensure brevity in your answer.  1. What is the ratio of the Female Labor Force(as % of total labor force) of Brunei Darussalam in 1995 to that in 1996?
Your answer should be compact. 0.97. What is the ratio of the Female Labor Force(as % of total labor force) in Cameroon in 1995 to that in 1996?
Your response must be concise. 0.99. What is the ratio of the Female Labor Force(as % of total labor force) of Suriname in 1995 to that in 1996?
Keep it short and to the point. 0.98. What is the ratio of the Female Labor Force(as % of total labor force) of Brunei Darussalam in 1995 to that in 1997?
Offer a very short reply. 0.95. What is the ratio of the Female Labor Force(as % of total labor force) in Cameroon in 1995 to that in 1997?
Keep it short and to the point. 0.99. What is the ratio of the Female Labor Force(as % of total labor force) in Suriname in 1995 to that in 1997?
Give a very brief answer. 0.97. What is the ratio of the Female Labor Force(as % of total labor force) of Brunei Darussalam in 1996 to that in 1997?
Ensure brevity in your answer.  0.97. What is the ratio of the Female Labor Force(as % of total labor force) in Cameroon in 1996 to that in 1997?
Keep it short and to the point. 1. What is the ratio of the Female Labor Force(as % of total labor force) of Suriname in 1996 to that in 1997?
Give a very brief answer. 0.98. What is the difference between the highest and the second highest Female Labor Force(as % of total labor force) in Brunei Darussalam?
Offer a terse response. 1.05. What is the difference between the highest and the second highest Female Labor Force(as % of total labor force) in Cameroon?
Give a very brief answer. 0.05. What is the difference between the highest and the second highest Female Labor Force(as % of total labor force) of Suriname?
Your answer should be very brief. 1.18. What is the difference between the highest and the lowest Female Labor Force(as % of total labor force) in Brunei Darussalam?
Your answer should be very brief. 5.65. What is the difference between the highest and the lowest Female Labor Force(as % of total labor force) of Cameroon?
Offer a very short reply. 3.19. What is the difference between the highest and the lowest Female Labor Force(as % of total labor force) in Suriname?
Ensure brevity in your answer.  5.66. 